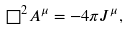<formula> <loc_0><loc_0><loc_500><loc_500>\square ^ { 2 } A ^ { \mu } = - 4 \pi J ^ { \mu } ,</formula> 